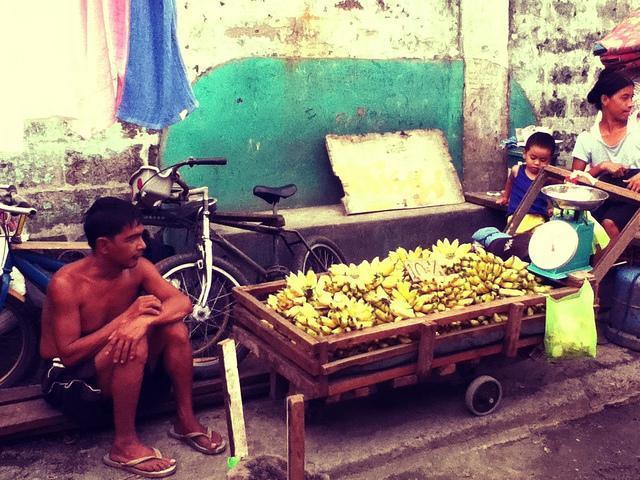How many bicycles are in the picture?
Give a very brief answer. 2. How many people are visible?
Give a very brief answer. 3. 